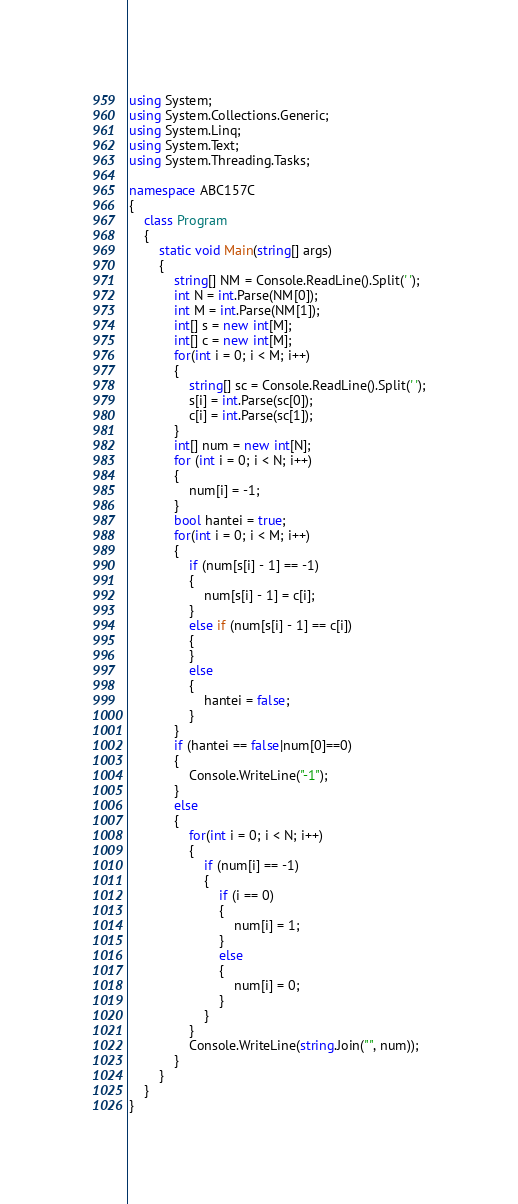Convert code to text. <code><loc_0><loc_0><loc_500><loc_500><_C#_>using System;
using System.Collections.Generic;
using System.Linq;
using System.Text;
using System.Threading.Tasks;

namespace ABC157C
{
    class Program
    {
        static void Main(string[] args)
        {
            string[] NM = Console.ReadLine().Split(' ');
            int N = int.Parse(NM[0]);
            int M = int.Parse(NM[1]);
            int[] s = new int[M];
            int[] c = new int[M];
            for(int i = 0; i < M; i++)
            {
                string[] sc = Console.ReadLine().Split(' ');
                s[i] = int.Parse(sc[0]);
                c[i] = int.Parse(sc[1]);
            }
            int[] num = new int[N];
            for (int i = 0; i < N; i++)
            {
                num[i] = -1;
            }
            bool hantei = true;
            for(int i = 0; i < M; i++)
            {
                if (num[s[i] - 1] == -1)
                {
                    num[s[i] - 1] = c[i];
                }
                else if (num[s[i] - 1] == c[i])
                {
                }
                else
                {
                    hantei = false;
                }
            }
            if (hantei == false|num[0]==0)
            {
                Console.WriteLine("-1");
            }
            else
            {
                for(int i = 0; i < N; i++)
                {
                    if (num[i] == -1)
                    {
                        if (i == 0)
                        {
                            num[i] = 1;
                        }
                        else
                        {
                            num[i] = 0;
                        }
                    }
                }
                Console.WriteLine(string.Join("", num));
            }
        }
    }
}
</code> 